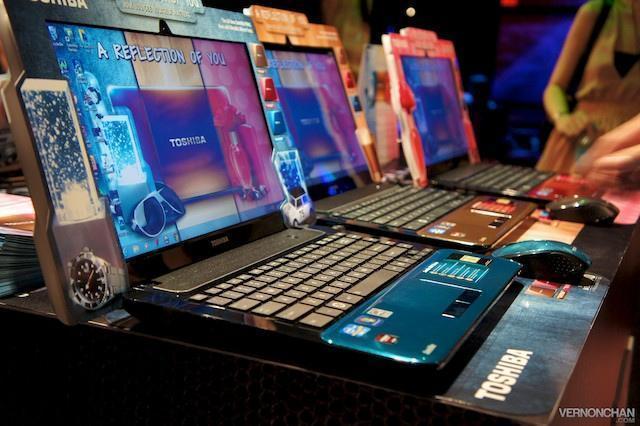What kind of label is on the desk?
Indicate the correct response by choosing from the four available options to answer the question.
Options: Instructional, directional, brand, regulatory. Brand. 